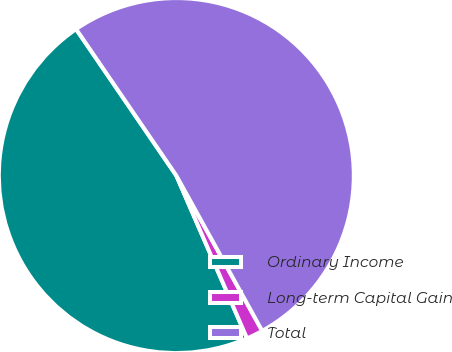Convert chart to OTSL. <chart><loc_0><loc_0><loc_500><loc_500><pie_chart><fcel>Ordinary Income<fcel>Long-term Capital Gain<fcel>Total<nl><fcel>46.97%<fcel>1.52%<fcel>51.51%<nl></chart> 